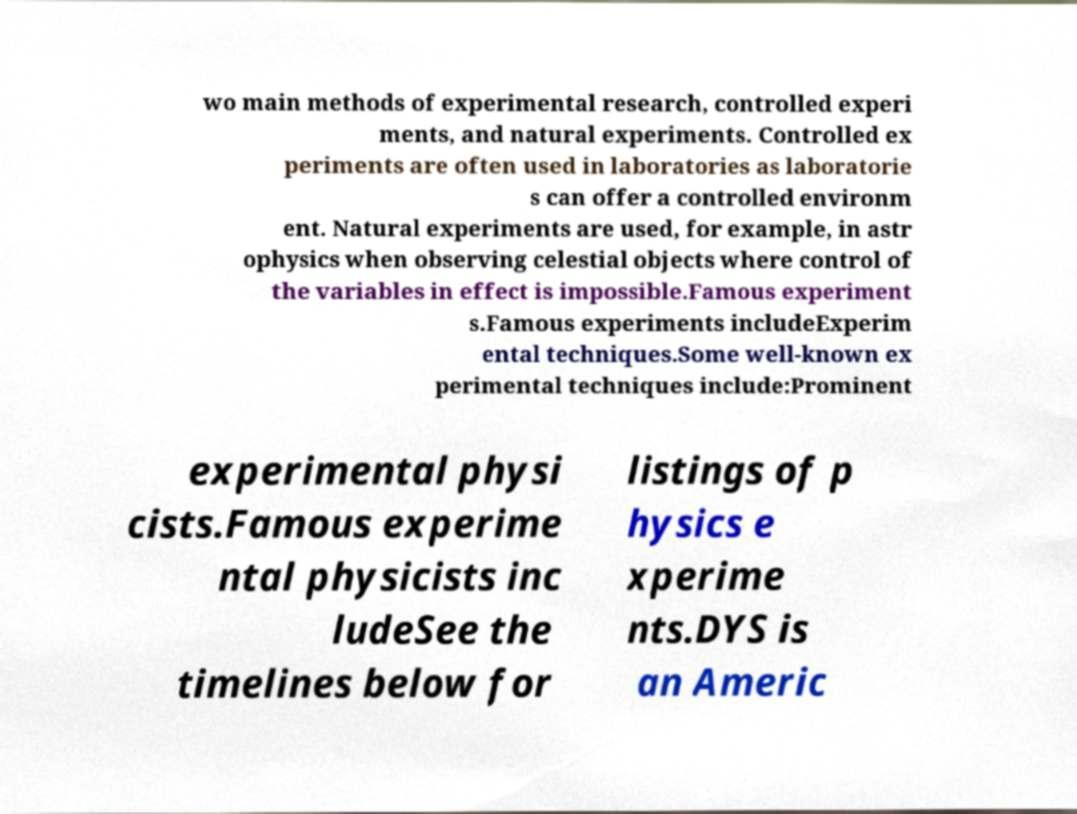There's text embedded in this image that I need extracted. Can you transcribe it verbatim? wo main methods of experimental research, controlled experi ments, and natural experiments. Controlled ex periments are often used in laboratories as laboratorie s can offer a controlled environm ent. Natural experiments are used, for example, in astr ophysics when observing celestial objects where control of the variables in effect is impossible.Famous experiment s.Famous experiments includeExperim ental techniques.Some well-known ex perimental techniques include:Prominent experimental physi cists.Famous experime ntal physicists inc ludeSee the timelines below for listings of p hysics e xperime nts.DYS is an Americ 